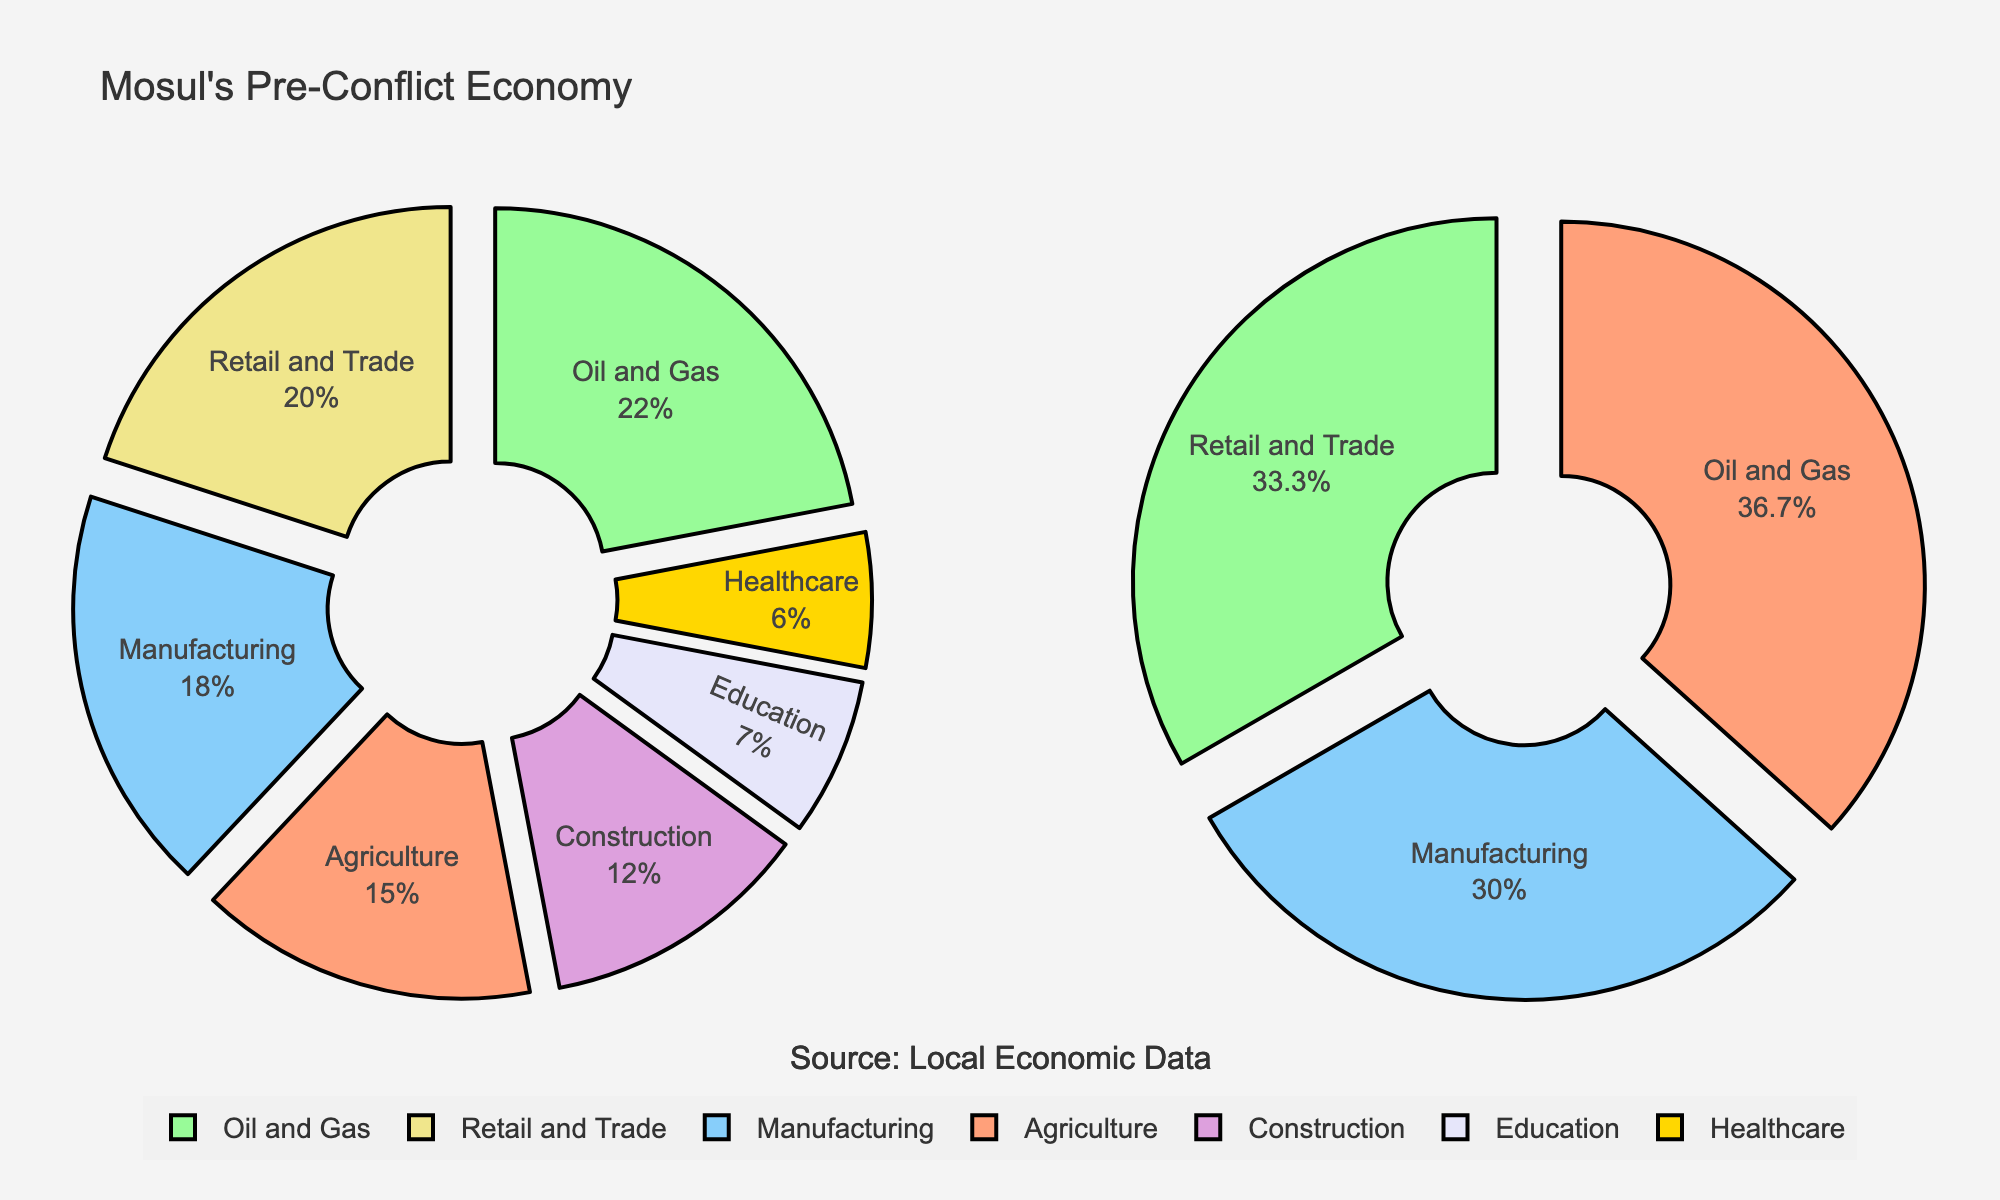What is the total percentage of expenses allocated to Health Insurance? On the education expenses pie chart, locate "Health Insurance" and note the percentage value indicated inside the corresponding segment.
Answer: 4% Which category has the largest slice in the Education Expenses pie chart? On the education expenses pie chart, identify the segment with the largest area. It is labeled with the category name.
Answer: Tuition What is the sum of expenses for Housing and Food? In the living expenses pie chart, locate "Housing" and "Food" segments, and read their values. Add these values: 12000 + 5000.
Answer: 17000 Are the Medical Equipment expenses higher or lower than Transportation expenses? Compare the size and value of the "Medical Equipment" segment in the education expenses chart with the "Transportation" segment in the living expenses chart.
Answer: Lower If Miscellaneous expenses were reduced by half, what would be the new value? Look at the "Miscellaneous" segment in the living expenses chart, take its value (3000), and divide by 2 to find the new amount.
Answer: 1500 What percentage of the total expenses is attributed to Textbooks? Find the "Textbooks" segment in the education expenses pie chart, and note the percentage label inside the segment indicating Textbooks.
Answer: 3% What is the combined percentage of Tuition and Textbooks expenses? Find the percentages for "Tuition" and "Textbooks" in the education expenses chart: 73% and 3%. Add these percentages: 73% + 3%.
Answer: 76% Which living expense category is closest in proportion to Health Insurance? Compare the size and percentage of "Health Insurance" in the education expenses chart with categories in the living expenses chart. The closest proportion will be the one with the most similar percentage.
Answer: Miscellaneous How does the pie chart for Education Expenses visually distinguish between different categories? Describe the differences in appearance such as color variations, sizes of each slice, and labels indicated inside each segment in Education Expenses pie chart.
Answer: Uses different colors and labeled segments What is the title of the entire figure? Look at the text at the very top of the figure. The title summarizes the overall content and provides a context for the pie charts.
Answer: Breakdown of Medical School Expenses 